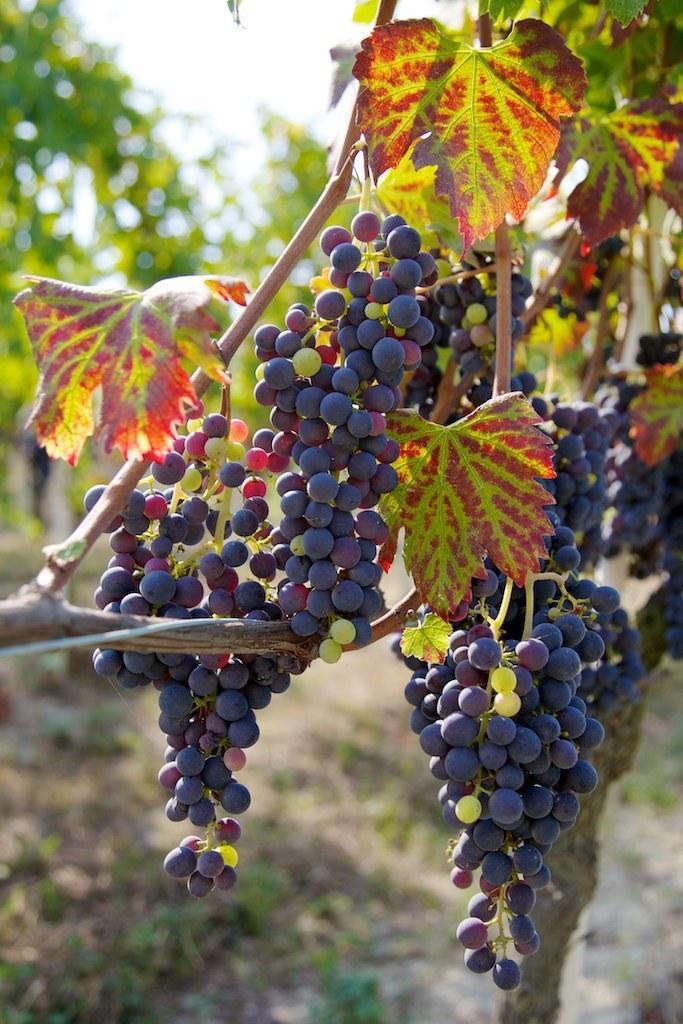How would you summarize this image in a sentence or two? In this picture I can see bunch of grapes to the tree and I can see few trees in the back and I can see sky. 